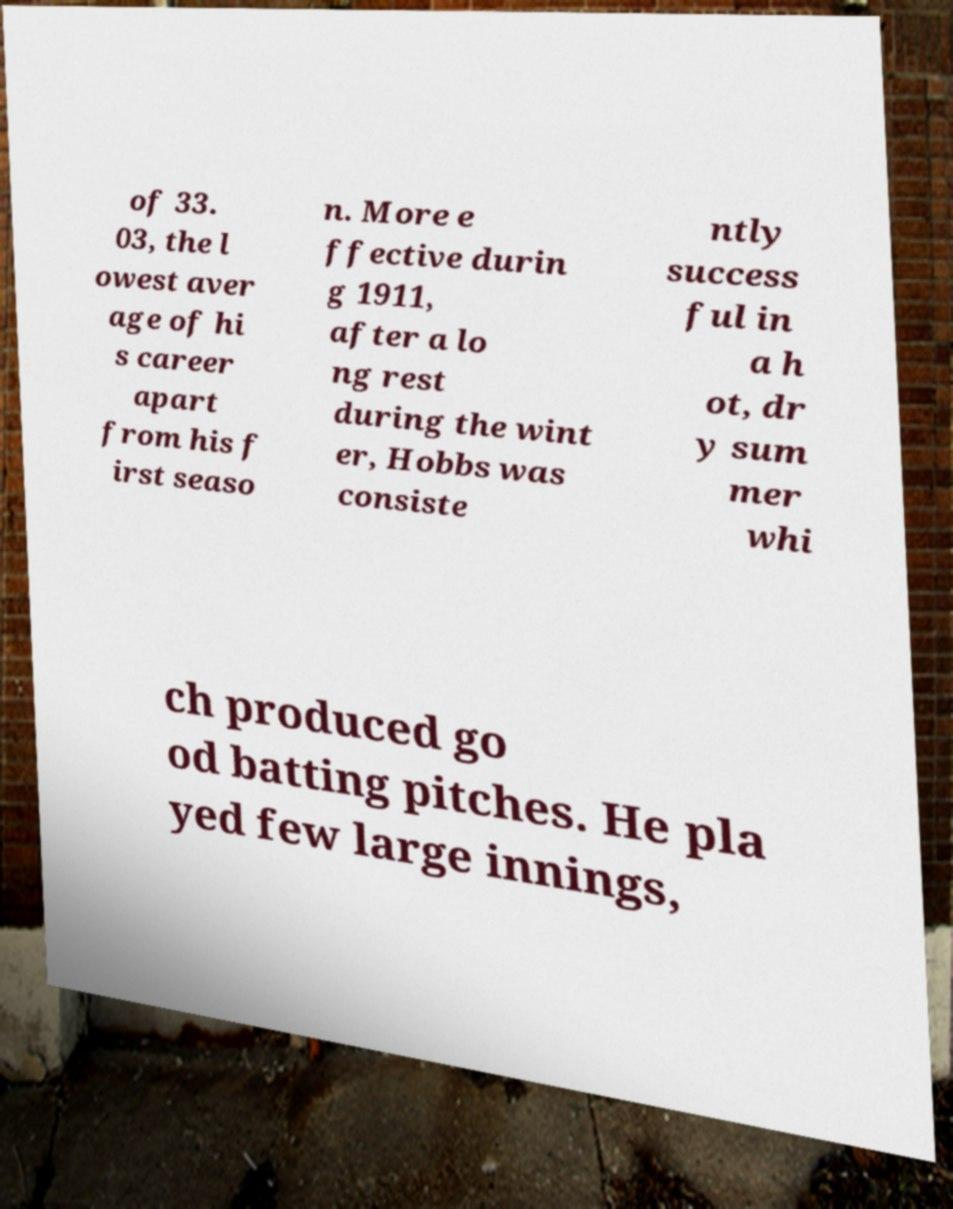For documentation purposes, I need the text within this image transcribed. Could you provide that? of 33. 03, the l owest aver age of hi s career apart from his f irst seaso n. More e ffective durin g 1911, after a lo ng rest during the wint er, Hobbs was consiste ntly success ful in a h ot, dr y sum mer whi ch produced go od batting pitches. He pla yed few large innings, 